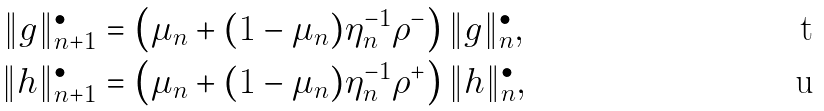Convert formula to latex. <formula><loc_0><loc_0><loc_500><loc_500>\| g \| ^ { \bullet } _ { n + 1 } & = \left ( \mu _ { n } + ( 1 - \mu _ { n } ) \eta ^ { - 1 } _ { n } \rho ^ { - } \right ) \| g \| ^ { \bullet } _ { n } , \\ \| h \| ^ { \bullet } _ { n + 1 } & = \left ( \mu _ { n } + ( 1 - \mu _ { n } ) \eta ^ { - 1 } _ { n } \rho ^ { + } \right ) \| h \| ^ { \bullet } _ { n } ,</formula> 